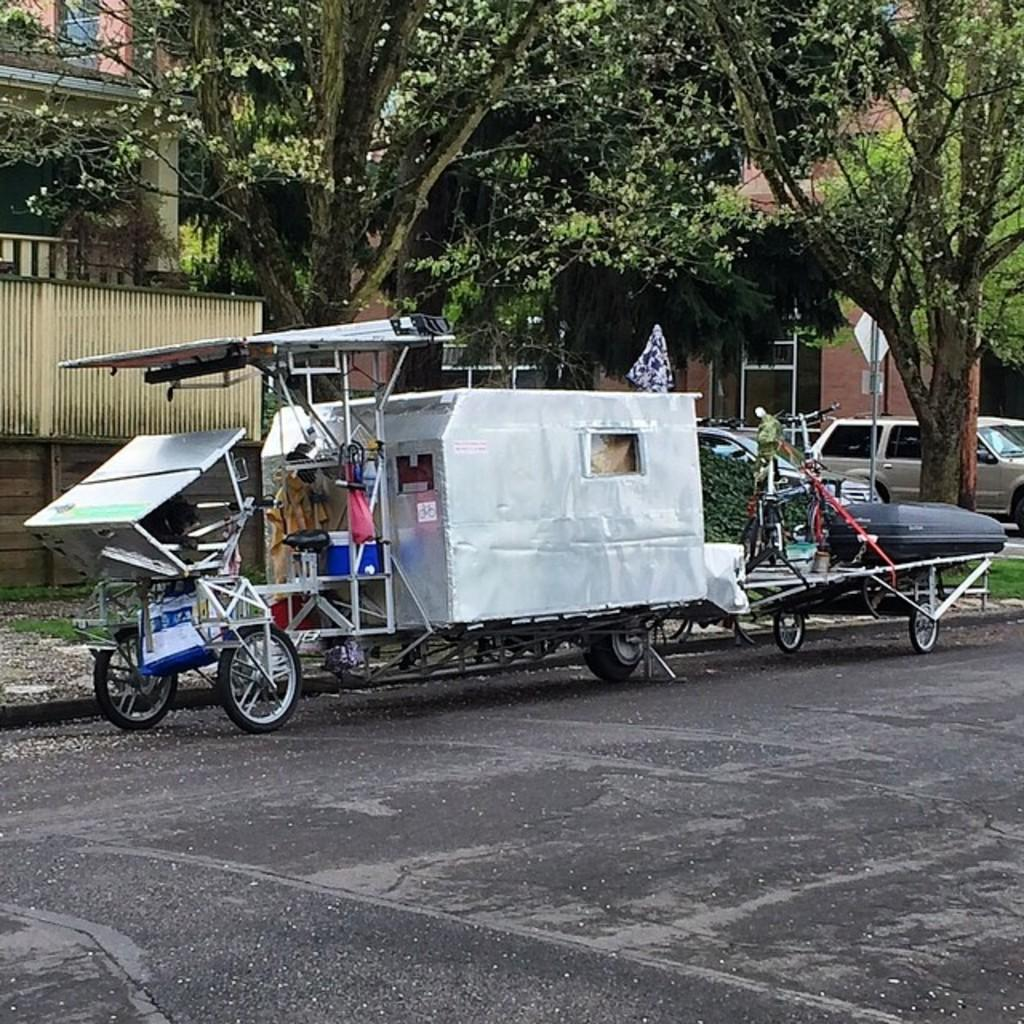What can be seen on the road in the image? There are vehicles on the road in the image. What is visible in the background of the image? There are trees, buildings, and sign boards in the background of the image. What is located on the left side of the image? There is a fence on the left side of the image. What type of rice is being cooked in the image? There is no rice present in the image; it features vehicles on the road, trees and buildings in the background, and a fence on the left side. What is the person learning in the image? There is no person learning anything in the image; it focuses on vehicles, trees, buildings, sign boards, and a fence. 